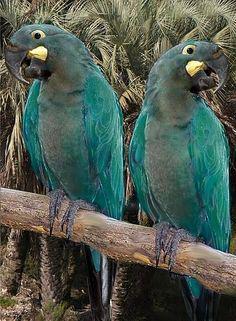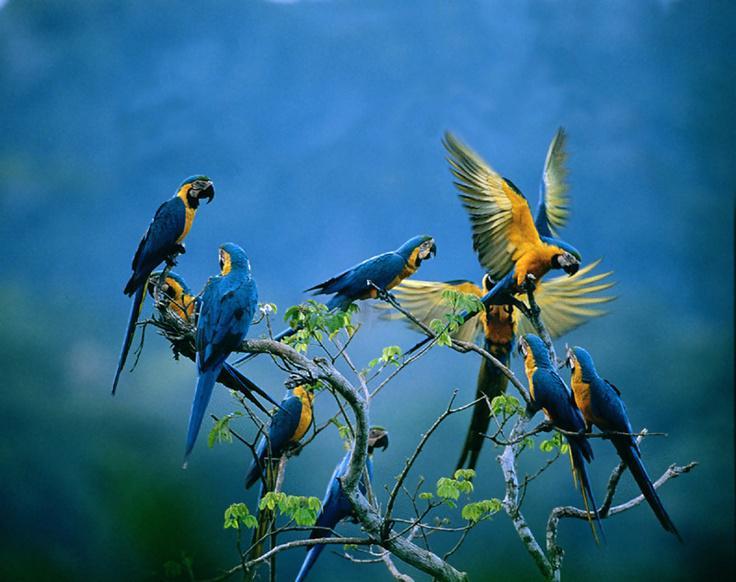The first image is the image on the left, the second image is the image on the right. For the images displayed, is the sentence "An image includes blue parrots with bright yellow chests." factually correct? Answer yes or no. Yes. The first image is the image on the left, the second image is the image on the right. Analyze the images presented: Is the assertion "There is at least one yellow breasted bird in the image on the left." valid? Answer yes or no. No. The first image is the image on the left, the second image is the image on the right. Assess this claim about the two images: "Two birds sit on a branch in the image on the right.". Correct or not? Answer yes or no. No. 